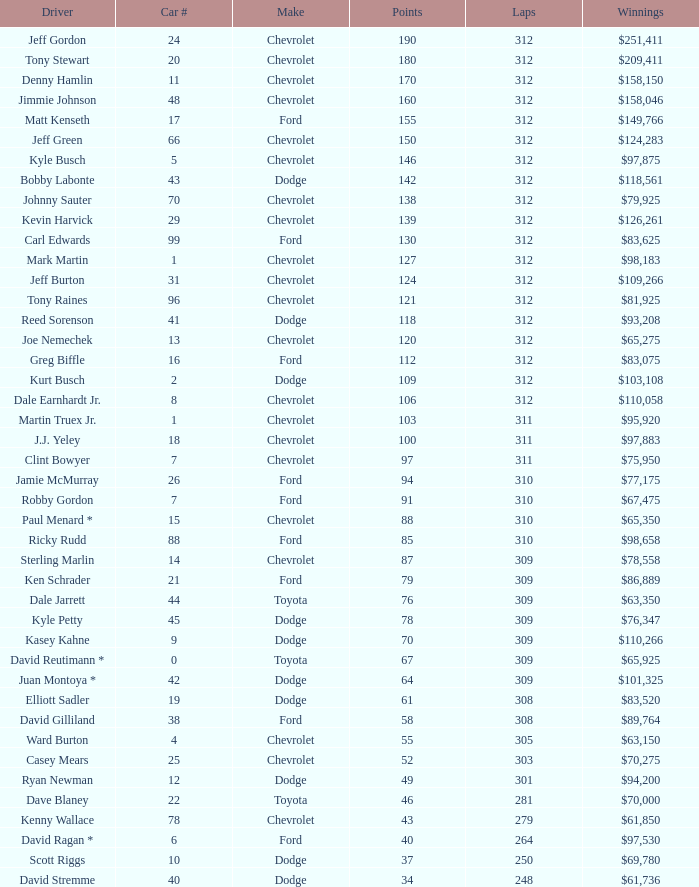What is the lowest number of laps for kyle petty with under 118 points? 309.0. 